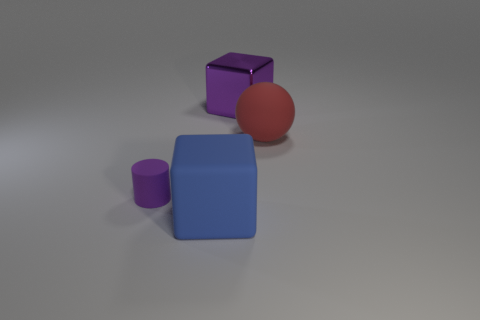Add 4 big purple cylinders. How many objects exist? 8 Subtract all spheres. How many objects are left? 3 Subtract 0 green cylinders. How many objects are left? 4 Subtract all large matte spheres. Subtract all purple cylinders. How many objects are left? 2 Add 1 large spheres. How many large spheres are left? 2 Add 3 purple things. How many purple things exist? 5 